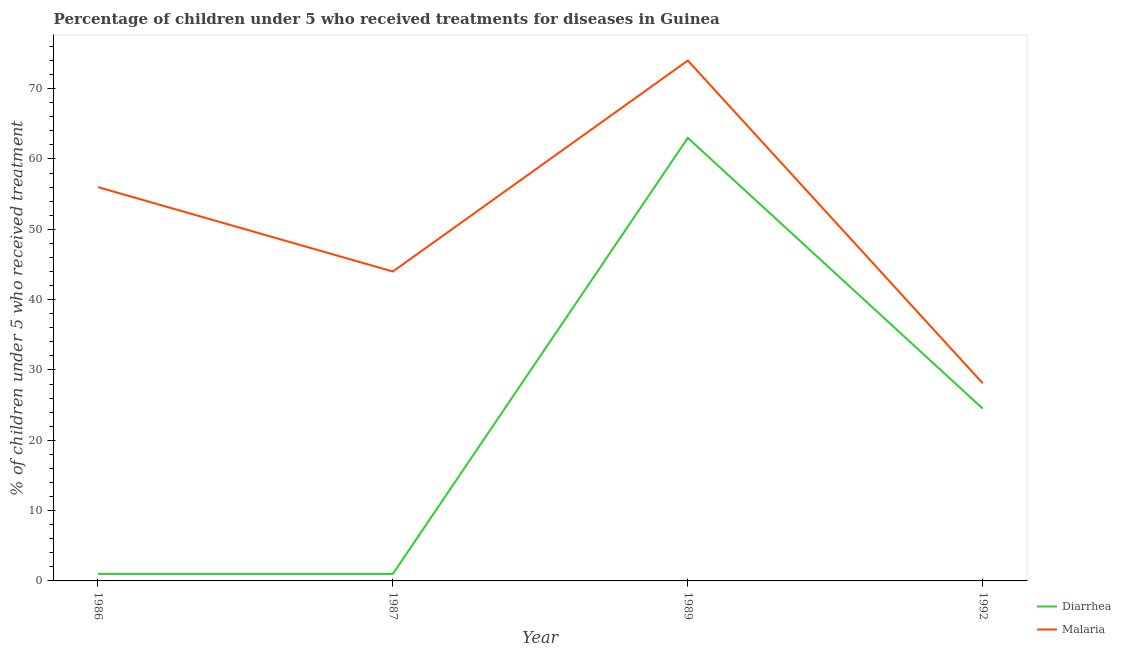Does the line corresponding to percentage of children who received treatment for diarrhoea intersect with the line corresponding to percentage of children who received treatment for malaria?
Offer a terse response. No. Across all years, what is the maximum percentage of children who received treatment for diarrhoea?
Give a very brief answer. 63. Across all years, what is the minimum percentage of children who received treatment for malaria?
Offer a very short reply. 28.1. In which year was the percentage of children who received treatment for diarrhoea maximum?
Provide a succinct answer. 1989. In which year was the percentage of children who received treatment for malaria minimum?
Ensure brevity in your answer.  1992. What is the total percentage of children who received treatment for diarrhoea in the graph?
Provide a short and direct response. 89.5. What is the difference between the percentage of children who received treatment for diarrhoea in 1986 and that in 1989?
Your answer should be compact. -62. What is the difference between the percentage of children who received treatment for diarrhoea in 1989 and the percentage of children who received treatment for malaria in 1992?
Provide a short and direct response. 34.9. What is the average percentage of children who received treatment for diarrhoea per year?
Your answer should be compact. 22.38. In the year 1986, what is the difference between the percentage of children who received treatment for diarrhoea and percentage of children who received treatment for malaria?
Provide a short and direct response. -55. What is the ratio of the percentage of children who received treatment for diarrhoea in 1986 to that in 1992?
Your answer should be compact. 0.04. Is the difference between the percentage of children who received treatment for diarrhoea in 1986 and 1987 greater than the difference between the percentage of children who received treatment for malaria in 1986 and 1987?
Your answer should be compact. No. What is the difference between the highest and the lowest percentage of children who received treatment for malaria?
Your response must be concise. 45.9. In how many years, is the percentage of children who received treatment for malaria greater than the average percentage of children who received treatment for malaria taken over all years?
Give a very brief answer. 2. Is the percentage of children who received treatment for diarrhoea strictly greater than the percentage of children who received treatment for malaria over the years?
Give a very brief answer. No. How many lines are there?
Offer a terse response. 2. How many years are there in the graph?
Your answer should be compact. 4. Does the graph contain grids?
Your answer should be compact. No. How many legend labels are there?
Provide a succinct answer. 2. How are the legend labels stacked?
Offer a terse response. Vertical. What is the title of the graph?
Your answer should be compact. Percentage of children under 5 who received treatments for diseases in Guinea. Does "Methane" appear as one of the legend labels in the graph?
Offer a terse response. No. What is the label or title of the Y-axis?
Offer a very short reply. % of children under 5 who received treatment. What is the % of children under 5 who received treatment of Diarrhea in 1987?
Give a very brief answer. 1. What is the % of children under 5 who received treatment of Malaria in 1987?
Offer a very short reply. 44. What is the % of children under 5 who received treatment of Malaria in 1989?
Your answer should be compact. 74. What is the % of children under 5 who received treatment of Diarrhea in 1992?
Offer a terse response. 24.5. What is the % of children under 5 who received treatment in Malaria in 1992?
Your answer should be compact. 28.1. Across all years, what is the minimum % of children under 5 who received treatment in Diarrhea?
Offer a very short reply. 1. Across all years, what is the minimum % of children under 5 who received treatment in Malaria?
Your response must be concise. 28.1. What is the total % of children under 5 who received treatment in Diarrhea in the graph?
Keep it short and to the point. 89.5. What is the total % of children under 5 who received treatment in Malaria in the graph?
Your response must be concise. 202.1. What is the difference between the % of children under 5 who received treatment in Diarrhea in 1986 and that in 1989?
Provide a succinct answer. -62. What is the difference between the % of children under 5 who received treatment in Diarrhea in 1986 and that in 1992?
Offer a very short reply. -23.5. What is the difference between the % of children under 5 who received treatment in Malaria in 1986 and that in 1992?
Your response must be concise. 27.9. What is the difference between the % of children under 5 who received treatment of Diarrhea in 1987 and that in 1989?
Your answer should be very brief. -62. What is the difference between the % of children under 5 who received treatment in Diarrhea in 1987 and that in 1992?
Provide a succinct answer. -23.5. What is the difference between the % of children under 5 who received treatment in Diarrhea in 1989 and that in 1992?
Your response must be concise. 38.5. What is the difference between the % of children under 5 who received treatment of Malaria in 1989 and that in 1992?
Provide a succinct answer. 45.9. What is the difference between the % of children under 5 who received treatment of Diarrhea in 1986 and the % of children under 5 who received treatment of Malaria in 1987?
Your answer should be compact. -43. What is the difference between the % of children under 5 who received treatment in Diarrhea in 1986 and the % of children under 5 who received treatment in Malaria in 1989?
Your answer should be compact. -73. What is the difference between the % of children under 5 who received treatment in Diarrhea in 1986 and the % of children under 5 who received treatment in Malaria in 1992?
Provide a short and direct response. -27.1. What is the difference between the % of children under 5 who received treatment of Diarrhea in 1987 and the % of children under 5 who received treatment of Malaria in 1989?
Offer a very short reply. -73. What is the difference between the % of children under 5 who received treatment of Diarrhea in 1987 and the % of children under 5 who received treatment of Malaria in 1992?
Keep it short and to the point. -27.1. What is the difference between the % of children under 5 who received treatment of Diarrhea in 1989 and the % of children under 5 who received treatment of Malaria in 1992?
Your response must be concise. 34.9. What is the average % of children under 5 who received treatment of Diarrhea per year?
Keep it short and to the point. 22.38. What is the average % of children under 5 who received treatment of Malaria per year?
Your answer should be very brief. 50.52. In the year 1986, what is the difference between the % of children under 5 who received treatment in Diarrhea and % of children under 5 who received treatment in Malaria?
Your response must be concise. -55. In the year 1987, what is the difference between the % of children under 5 who received treatment of Diarrhea and % of children under 5 who received treatment of Malaria?
Ensure brevity in your answer.  -43. In the year 1992, what is the difference between the % of children under 5 who received treatment in Diarrhea and % of children under 5 who received treatment in Malaria?
Offer a terse response. -3.6. What is the ratio of the % of children under 5 who received treatment of Diarrhea in 1986 to that in 1987?
Ensure brevity in your answer.  1. What is the ratio of the % of children under 5 who received treatment of Malaria in 1986 to that in 1987?
Keep it short and to the point. 1.27. What is the ratio of the % of children under 5 who received treatment in Diarrhea in 1986 to that in 1989?
Your answer should be compact. 0.02. What is the ratio of the % of children under 5 who received treatment of Malaria in 1986 to that in 1989?
Your response must be concise. 0.76. What is the ratio of the % of children under 5 who received treatment in Diarrhea in 1986 to that in 1992?
Your answer should be compact. 0.04. What is the ratio of the % of children under 5 who received treatment of Malaria in 1986 to that in 1992?
Give a very brief answer. 1.99. What is the ratio of the % of children under 5 who received treatment in Diarrhea in 1987 to that in 1989?
Make the answer very short. 0.02. What is the ratio of the % of children under 5 who received treatment of Malaria in 1987 to that in 1989?
Provide a short and direct response. 0.59. What is the ratio of the % of children under 5 who received treatment of Diarrhea in 1987 to that in 1992?
Make the answer very short. 0.04. What is the ratio of the % of children under 5 who received treatment in Malaria in 1987 to that in 1992?
Ensure brevity in your answer.  1.57. What is the ratio of the % of children under 5 who received treatment in Diarrhea in 1989 to that in 1992?
Offer a very short reply. 2.57. What is the ratio of the % of children under 5 who received treatment of Malaria in 1989 to that in 1992?
Your answer should be very brief. 2.63. What is the difference between the highest and the second highest % of children under 5 who received treatment in Diarrhea?
Ensure brevity in your answer.  38.5. What is the difference between the highest and the lowest % of children under 5 who received treatment in Malaria?
Your answer should be very brief. 45.9. 